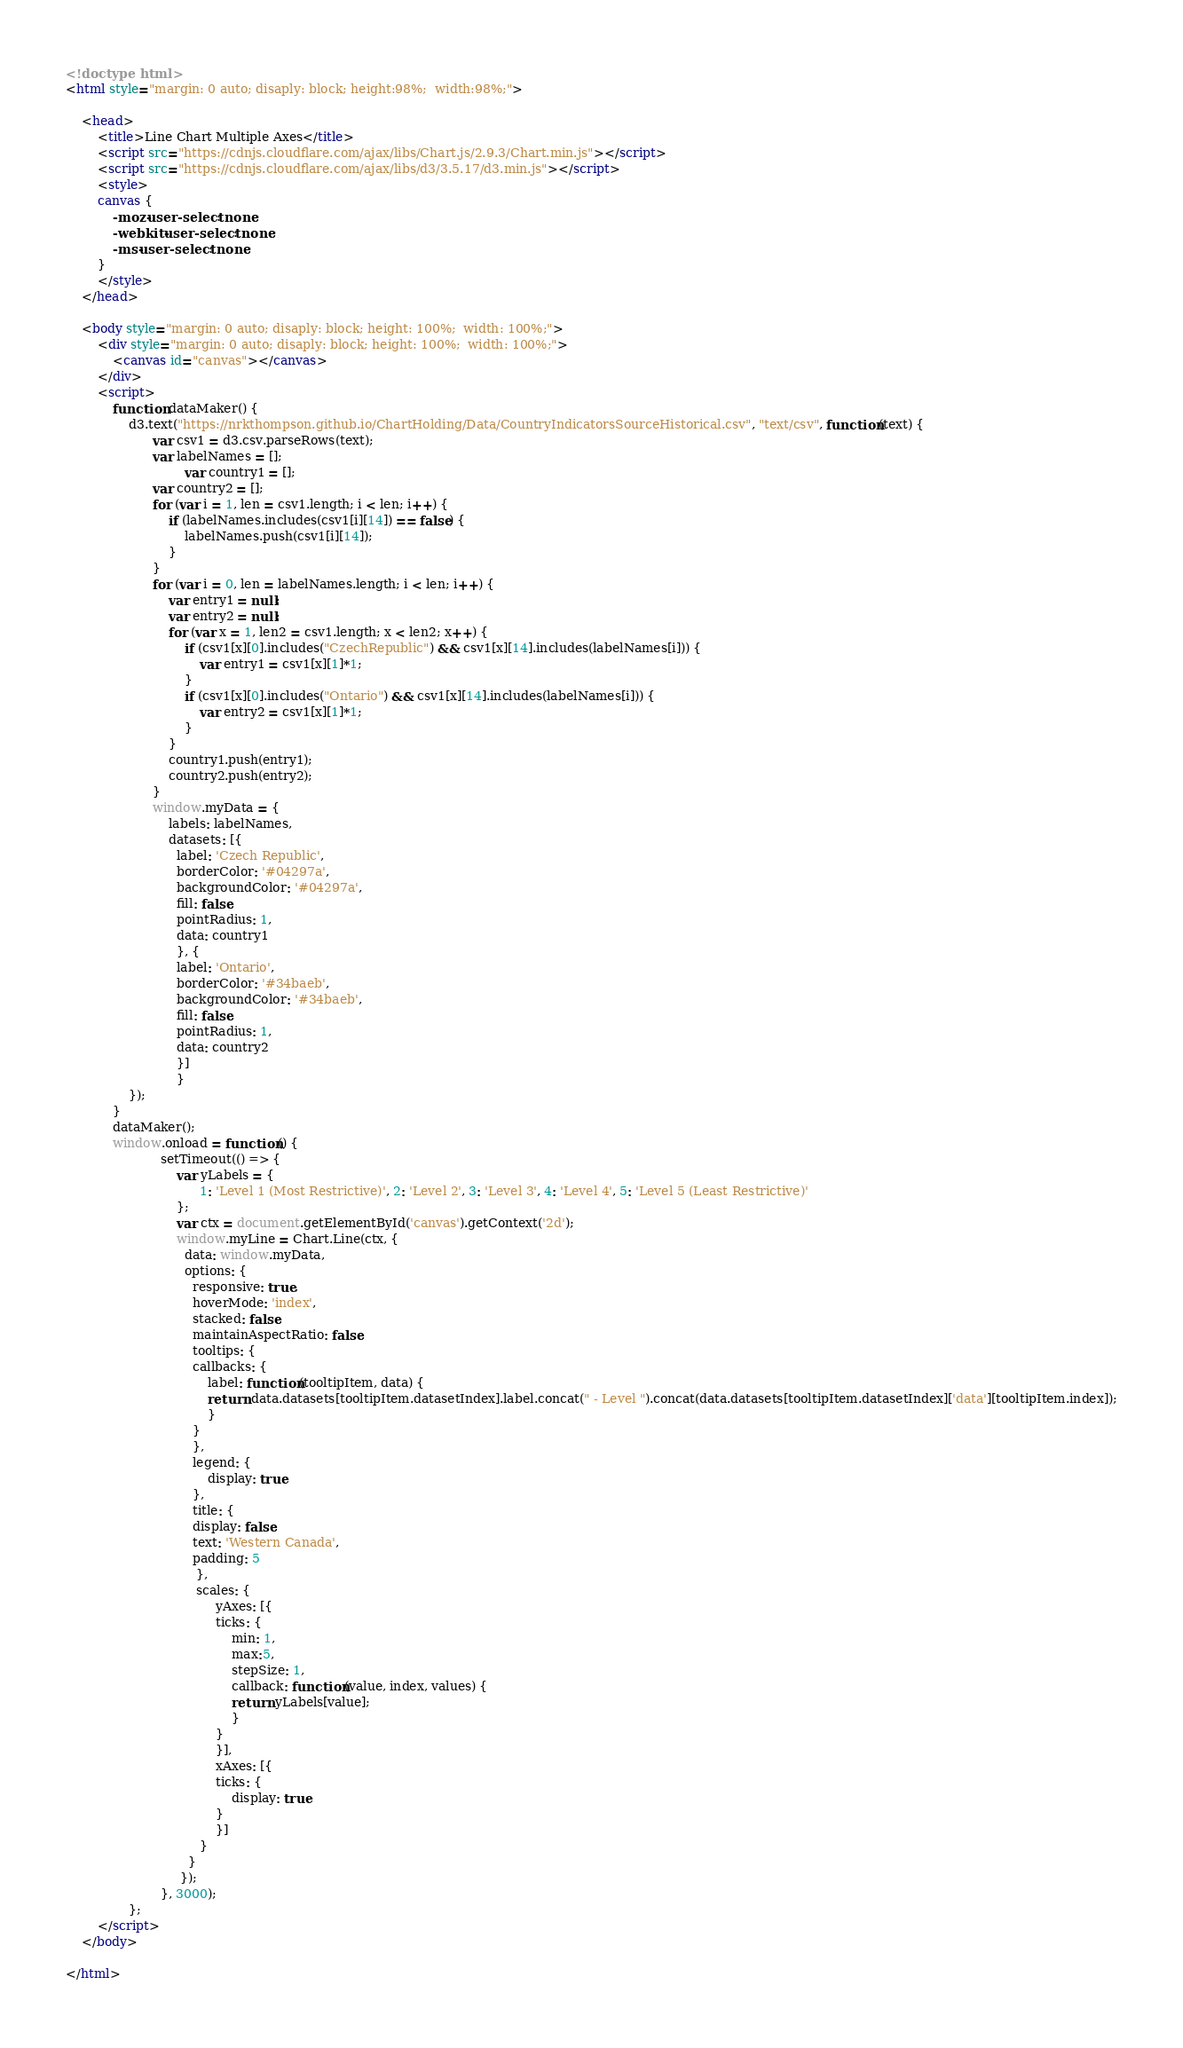Convert code to text. <code><loc_0><loc_0><loc_500><loc_500><_HTML_>
<!doctype html>
<html style="margin: 0 auto; disaply: block; height:98%;  width:98%;">

	<head>
		<title>Line Chart Multiple Axes</title>
		<script src="https://cdnjs.cloudflare.com/ajax/libs/Chart.js/2.9.3/Chart.min.js"></script>
		<script src="https://cdnjs.cloudflare.com/ajax/libs/d3/3.5.17/d3.min.js"></script>
		<style>
		canvas {
			-moz-user-select: none;
			-webkit-user-select: none;
			-ms-user-select: none;
		}
		</style>
	</head>

	<body style="margin: 0 auto; disaply: block; height: 100%;  width: 100%;">
		<div style="margin: 0 auto; disaply: block; height: 100%;  width: 100%;">
			<canvas id="canvas"></canvas>
		</div>
		<script>
			function dataMaker() {
				d3.text("https://nrkthompson.github.io/ChartHolding/Data/CountryIndicatorsSourceHistorical.csv", "text/csv", function(text) {
					  var csv1 = d3.csv.parseRows(text);
					  var labelNames = [];
            				  var country1 = [];
					  var country2 = [];
					  for (var i = 1, len = csv1.length; i < len; i++) {
						  if (labelNames.includes(csv1[i][14]) == false) {
							  labelNames.push(csv1[i][14]);
						  }
					  }
					  for (var i = 0, len = labelNames.length; i < len; i++) {
						  var entry1 = null;
						  var entry2 = null;
						  for (var x = 1, len2 = csv1.length; x < len2; x++) {
							  if (csv1[x][0].includes("CzechRepublic") && csv1[x][14].includes(labelNames[i])) {
								  var entry1 = csv1[x][1]*1;
							  }
							  if (csv1[x][0].includes("Ontario") && csv1[x][14].includes(labelNames[i])) {
								  var entry2 = csv1[x][1]*1;
							  }
						  }
						  country1.push(entry1);
						  country2.push(entry2);
					  }
					  window.myData = {
						  labels: labelNames,
						  datasets: [{
						    label: 'Czech Republic',
						    borderColor: '#04297a',
						    backgroundColor: '#04297a',
						    fill: false,
						    pointRadius: 1,
						    data: country1
						    }, {
						    label: 'Ontario',
						    borderColor: '#34baeb',
						    backgroundColor: '#34baeb',
						    fill: false,
						    pointRadius: 1,
						    data: country2
						    }]
						    }  
				});
			}
			dataMaker();
			window.onload = function() {
						setTimeout(() => { 
							var yLabels = {
							      1: 'Level 1 (Most Restrictive)', 2: 'Level 2', 3: 'Level 3', 4: 'Level 4', 5: 'Level 5 (Least Restrictive)'
							};
							var ctx = document.getElementById('canvas').getContext('2d');
							window.myLine = Chart.Line(ctx, {
							  data: window.myData,
							  options: {
							    responsive: true,
							    hoverMode: 'index',
							    stacked: false,
							    maintainAspectRatio: false,
							    tooltips: {
								callbacks: {
								    label: function(tooltipItem, data) {
									return data.datasets[tooltipItem.datasetIndex].label.concat(" - Level ").concat(data.datasets[tooltipItem.datasetIndex]['data'][tooltipItem.index]);
								    }
								}
							    },
							    legend: {
								    display: true
							    },
							    title: {
								display: false,
								text: 'Western Canada',
								padding: 5
							     },
							     scales: {
								      yAxes: [{
									  ticks: {
									      min: 1,
									      max:5,
									      stepSize: 1,
									      callback: function(value, index, values) {
										  return yLabels[value];
									      }
									  }
								      }],
								      xAxes: [{
									  ticks: {
									      display: true
									  }
								      }]
								  }
							   }
							 });
						}, 3000);
				};
		</script>
	</body>

</html></code> 